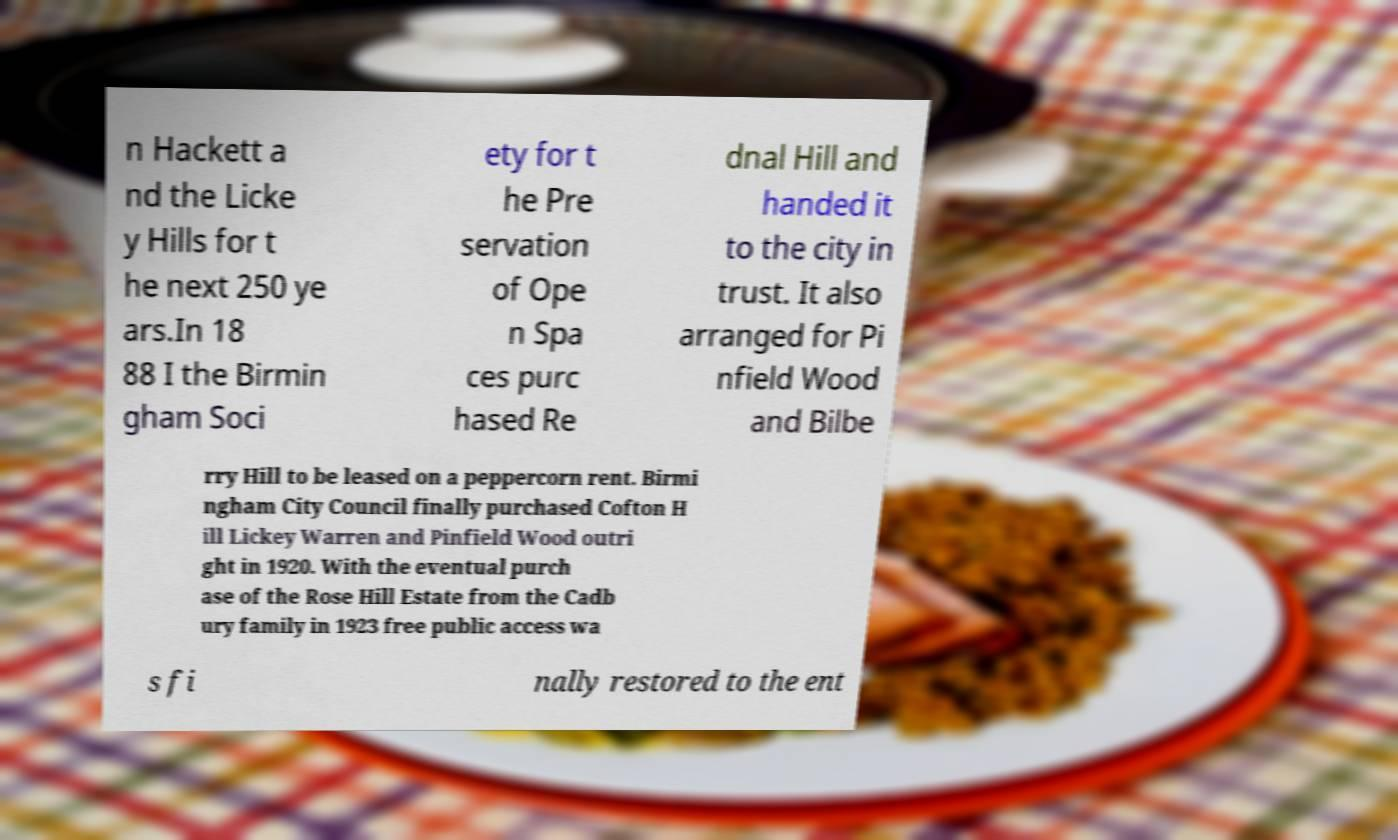Please read and relay the text visible in this image. What does it say? n Hackett a nd the Licke y Hills for t he next 250 ye ars.In 18 88 I the Birmin gham Soci ety for t he Pre servation of Ope n Spa ces purc hased Re dnal Hill and handed it to the city in trust. It also arranged for Pi nfield Wood and Bilbe rry Hill to be leased on a peppercorn rent. Birmi ngham City Council finally purchased Cofton H ill Lickey Warren and Pinfield Wood outri ght in 1920. With the eventual purch ase of the Rose Hill Estate from the Cadb ury family in 1923 free public access wa s fi nally restored to the ent 